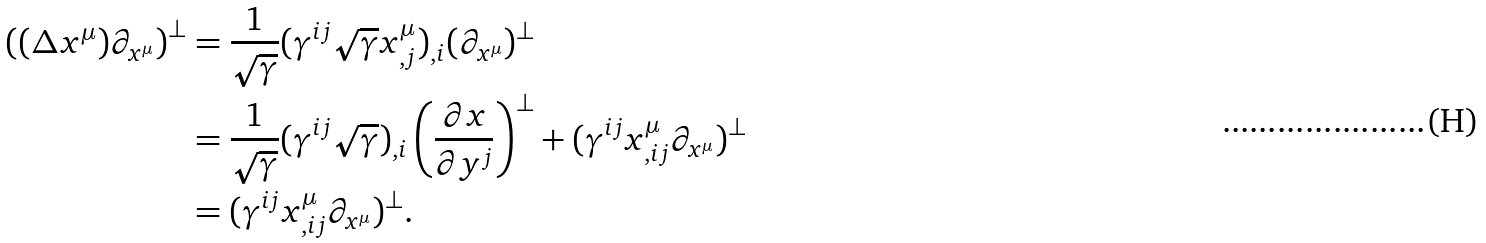<formula> <loc_0><loc_0><loc_500><loc_500>\left ( ( \Delta x ^ { \mu } ) \partial _ { x ^ { \mu } } \right ) ^ { \bot } & = \frac { 1 } { \sqrt { \gamma } } ( \gamma ^ { i j } \sqrt { \gamma } x _ { , j } ^ { \mu } ) _ { , i } ( \partial _ { x ^ { \mu } } ) ^ { \bot } \\ & = \frac { 1 } { \sqrt { \gamma } } ( \gamma ^ { i j } \sqrt { \gamma } ) _ { , i } \left ( \frac { \partial x } { \partial y ^ { j } } \right ) ^ { \bot } + ( \gamma ^ { i j } x _ { , i j } ^ { \mu } \partial _ { x ^ { \mu } } ) ^ { \bot } \\ & = ( \gamma ^ { i j } x _ { , i j } ^ { \mu } \partial _ { x ^ { \mu } } ) ^ { \bot } .</formula> 